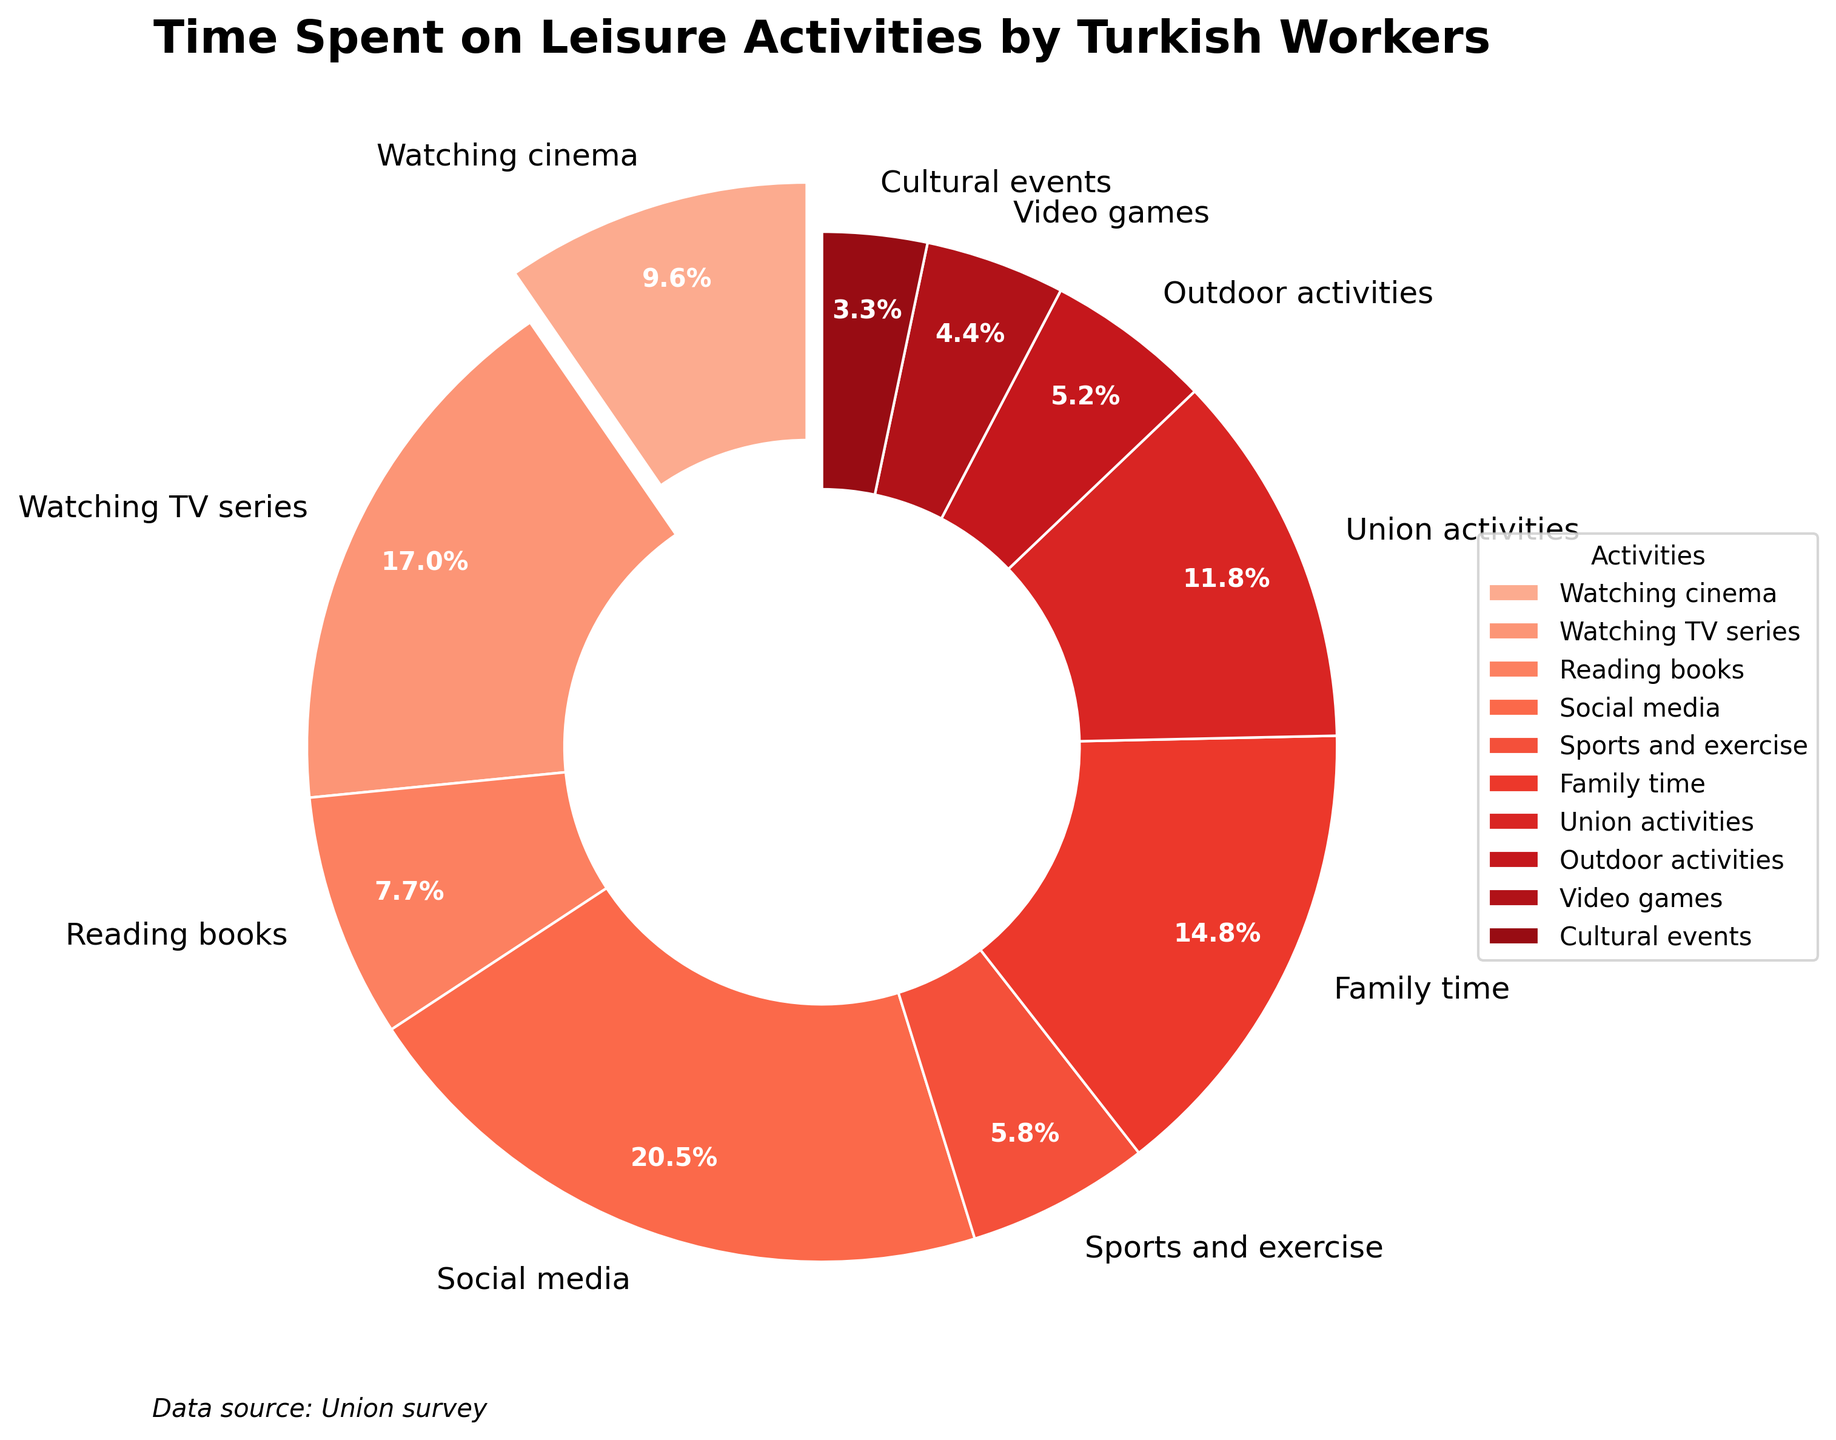Which activity do Turkish workers spend the most time on for leisure? By looking at the pie chart, the largest slice represents the activity Turkish workers spend the most time on. The largest slice corresponds to Social media.
Answer: Social media How much time do Turkish workers spend on family time compared to union activities? We need to compare the slices labeled Family time and Union activities. The Family time slice corresponds to 5.4 hours per week, while the Union activities slice corresponds to 4.3 hours per week.
Answer: 5.4 hours for Family time, 4.3 hours for Union activities What is the total time spent by Turkish workers on watching TV series and social media? We need to sum the hours spent on Watching TV series and Social media. Watching TV series is 6.2 hours and Social media is 7.5 hours. Therefore, the total is 6.2 + 7.5 = 13.7 hours.
Answer: 13.7 hours Which activity do Turkish workers spend the least time on for leisure? The smallest slice in the pie chart represents the activity with the least time spent. The smallest slice corresponds to Cultural events.
Answer: Cultural events How does the time spent on sports and exercise compare to playing video games? Compare the slices labeled Sports and exercise (2.1 hours) and Video games (1.6 hours). Sports and exercise has a larger slice with 0.5 more hours than Video games.
Answer: Sports and exercise is 0.5 hours more Is the time spent on reading books greater than the time spent on outdoor activities and video games combined? Sum the hours for Outdoor activities (1.9 hours) and Video games (1.6 hours) to get 1.9 + 1.6 = 3.5 hours. Compare this to Reading books (2.8 hours). Reading books is 0.7 hours less.
Answer: No, it's 0.7 hours less What percentage of leisure time is spent on activities other than social media? Find the percentage of time spent on Social media (7.5 hours) and subtract from 100%. The total hours summed up from the pie chart is 36.5. Hence, (7.5 / 36.5) * 100 ≈ 20.5%, and so 100 - 20.5 = 79.5%.
Answer: 79.5% If workers allocated an equal percentage of their time to cinema and union activities, how much time would that be for each? Calculate the average of Watching cinema (3.5 hours) and Union activities (4.3 hours). The sum is 3.5 + 4.3 = 7.8 hours. Dividing by 2 gives 7.8 / 2 = 3.9 hours.
Answer: 3.9 hours Which visual attribute helps highlight the cinema activity in the pie chart? The slice for Watching cinema is slightly separated from the rest of the pie chart, making it stand out.
Answer: The slice is separated (exploded) What fraction of their leisure time do Turkish workers spend on activities involving screens (Watching cinema, Watching TV series, Social media, and Video games)? Sum the hours spent on Watching cinema (3.5), Watching TV series (6.2), Social media (7.5), and Video games (1.6) to get 3.5 + 6.2 + 7.5 + 1.6 = 18.8 hours. The total is 36.5 hours. Therefore, the fraction is 18.8 / 36.5 ≈ 0.515, or about 51.5%.
Answer: 51.5% 